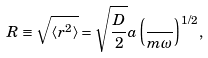Convert formula to latex. <formula><loc_0><loc_0><loc_500><loc_500>R \equiv \sqrt { \langle r ^ { 2 } \rangle } = \sqrt { \frac { D } { 2 } } a \left ( \frac { } { m \omega } \right ) ^ { 1 / 2 } ,</formula> 